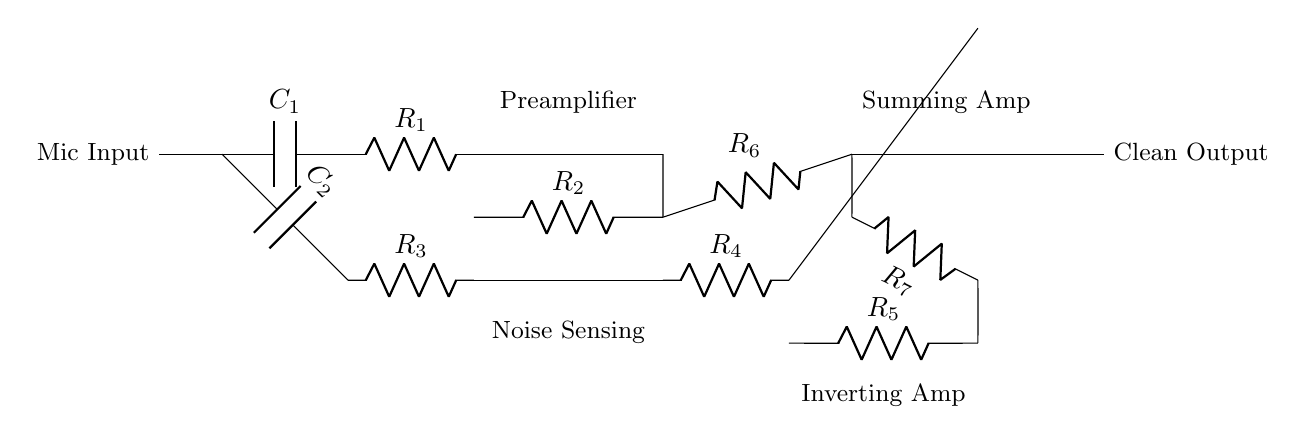What component is used for noise sensing? The component used for noise sensing in this circuit is the capacitor labeled C2. It is connected to the noise sensing section, indicating that it plays a role in detecting unwanted sounds.
Answer: Capacitor C2 What is the function of the first operational amplifier? The first operational amplifier in the preamplifier section amplifies the mic input signal after it passes through the capacitor and resistor, enhancing the input signal for further processing.
Answer: Preamplifier How many resistors are there in total? To find the answer, count all the resistors indicated on the circuit diagram: R1, R2, R3, R4, R5, R6, and R7, yielding a total of seven resistors.
Answer: Seven What does the summing amplifier do? The summing amplifier combines signals from the preamplifier and the inverting amplifier, using operational amplifiers and resistors, to produce a clean output that effectively cancels noise.
Answer: Combines signals What is the role of capacitor C1 in the circuit? Capacitor C1 is connected to the microphone input and likely serves to block DC and allow AC signals to pass through, thus preventing unwanted DC offsets from reaching the active components.
Answer: Block DC Which stage of the circuit has an inverting configuration? The inverting amplifier stage can be identified as it employs an operational amplifier arranged to invert the phase of its input signal, resulting in an output that is an inverted version of the input.
Answer: Inverting amplifier What is the expected output of this circuit? The circuit is designed to produce a clean audio output that has minimized noise, suitable for high-quality radio broadcasting by effectively cancelling out background interference.
Answer: Clean output 